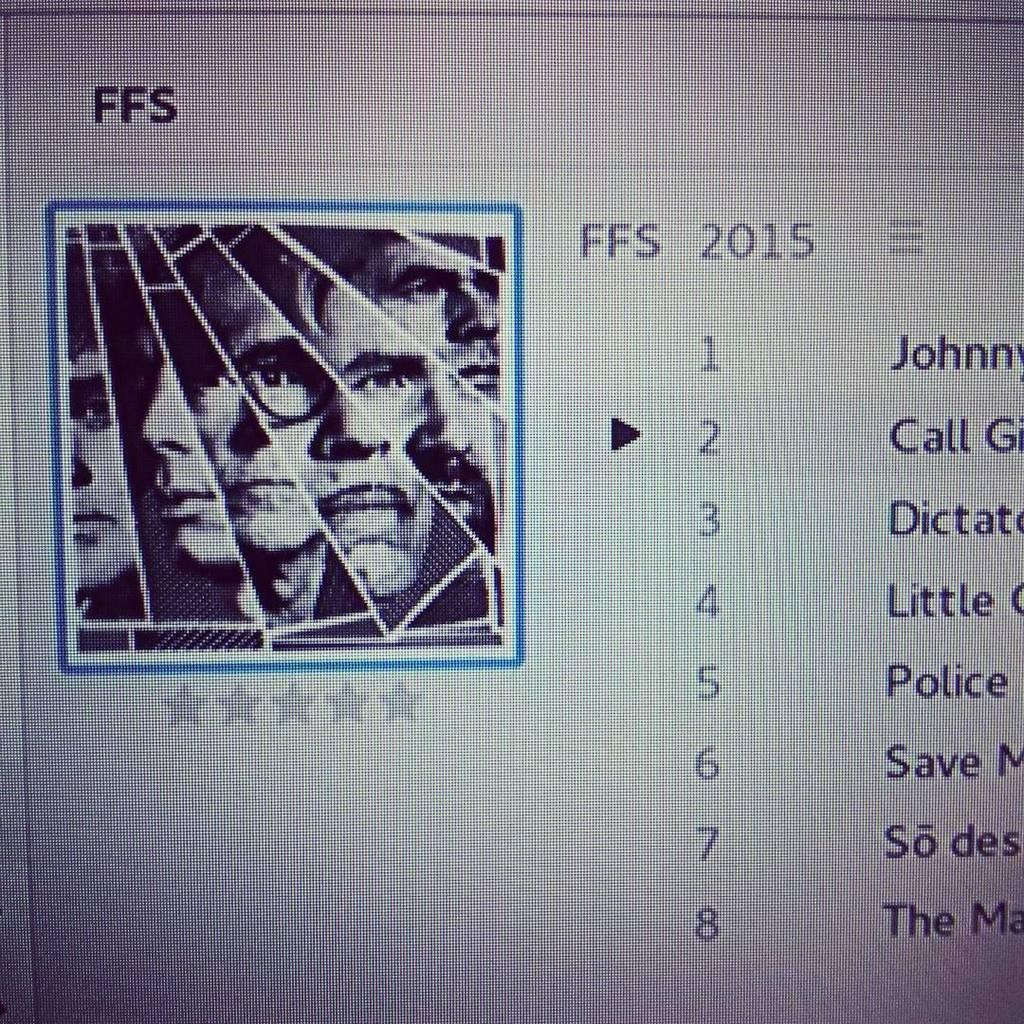How would you summarize this image in a sentence or two? In this picture we can see a screen with some listing and cursor pointing at number 2. On left side we can see a collage image of a man with different shades and below the picture we can see five stars. 